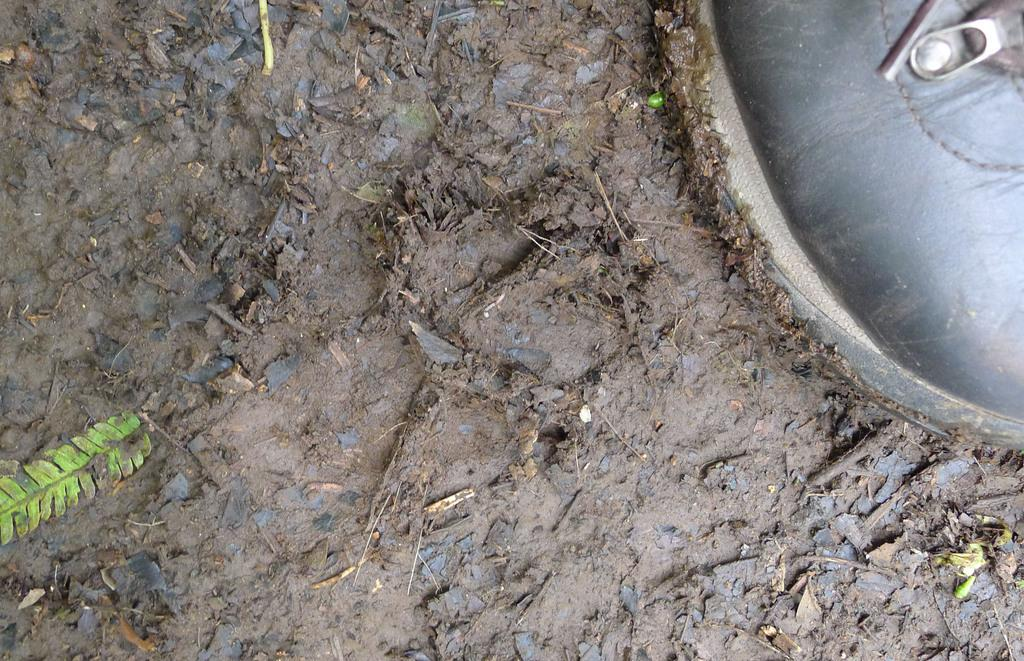What is the condition of the ground in the image? The ground in the image is covered with wet mud. What can be seen on the ground in the image? There is a black color shoe in the image. Whose shoe is it in the image? The shoe belongs to a person. How is the shoe affected by the wet mud? The corners of the shoe are covered with mud. What is the title of the book the person is reading in the image? There is no book or person reading in the image; it only shows a shoe on wet mud. What type of shame is the person experiencing in the image? There is no person or indication of shame in the image; it only shows a shoe on wet mud. 